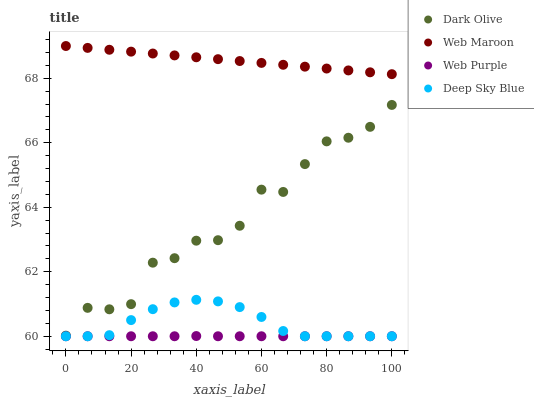Does Web Purple have the minimum area under the curve?
Answer yes or no. Yes. Does Web Maroon have the maximum area under the curve?
Answer yes or no. Yes. Does Dark Olive have the minimum area under the curve?
Answer yes or no. No. Does Dark Olive have the maximum area under the curve?
Answer yes or no. No. Is Web Maroon the smoothest?
Answer yes or no. Yes. Is Dark Olive the roughest?
Answer yes or no. Yes. Is Dark Olive the smoothest?
Answer yes or no. No. Is Web Maroon the roughest?
Answer yes or no. No. Does Web Purple have the lowest value?
Answer yes or no. Yes. Does Dark Olive have the lowest value?
Answer yes or no. No. Does Web Maroon have the highest value?
Answer yes or no. Yes. Does Dark Olive have the highest value?
Answer yes or no. No. Is Web Purple less than Web Maroon?
Answer yes or no. Yes. Is Web Maroon greater than Web Purple?
Answer yes or no. Yes. Does Deep Sky Blue intersect Web Purple?
Answer yes or no. Yes. Is Deep Sky Blue less than Web Purple?
Answer yes or no. No. Is Deep Sky Blue greater than Web Purple?
Answer yes or no. No. Does Web Purple intersect Web Maroon?
Answer yes or no. No. 